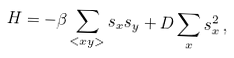<formula> <loc_0><loc_0><loc_500><loc_500>H = - \beta \sum _ { < x y > } s _ { x } s _ { y } + D \sum _ { x } s _ { x } ^ { 2 } \, ,</formula> 